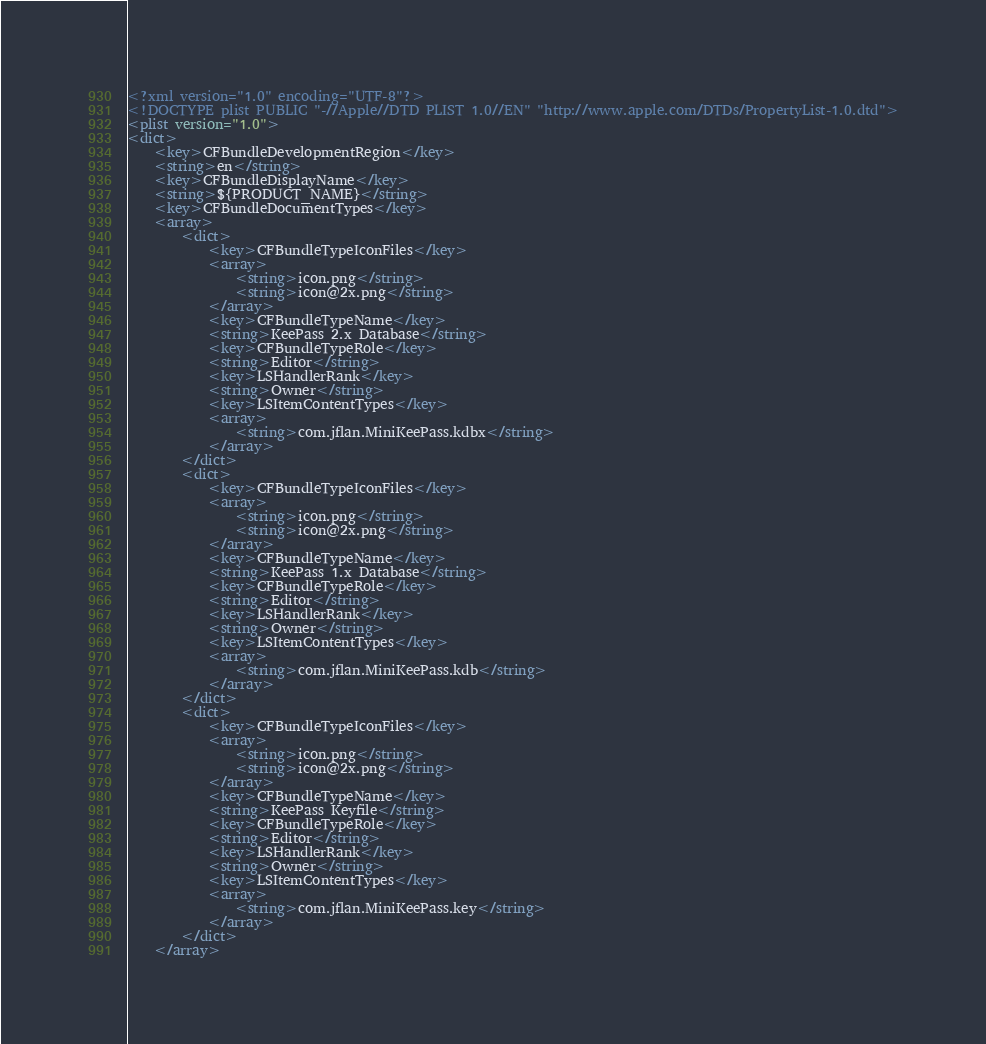<code> <loc_0><loc_0><loc_500><loc_500><_XML_><?xml version="1.0" encoding="UTF-8"?>
<!DOCTYPE plist PUBLIC "-//Apple//DTD PLIST 1.0//EN" "http://www.apple.com/DTDs/PropertyList-1.0.dtd">
<plist version="1.0">
<dict>
	<key>CFBundleDevelopmentRegion</key>
	<string>en</string>
	<key>CFBundleDisplayName</key>
	<string>${PRODUCT_NAME}</string>
	<key>CFBundleDocumentTypes</key>
	<array>
		<dict>
			<key>CFBundleTypeIconFiles</key>
			<array>
				<string>icon.png</string>
				<string>icon@2x.png</string>
			</array>
			<key>CFBundleTypeName</key>
			<string>KeePass 2.x Database</string>
			<key>CFBundleTypeRole</key>
			<string>Editor</string>
			<key>LSHandlerRank</key>
			<string>Owner</string>
			<key>LSItemContentTypes</key>
			<array>
				<string>com.jflan.MiniKeePass.kdbx</string>
			</array>
		</dict>
		<dict>
			<key>CFBundleTypeIconFiles</key>
			<array>
				<string>icon.png</string>
				<string>icon@2x.png</string>
			</array>
			<key>CFBundleTypeName</key>
			<string>KeePass 1.x Database</string>
			<key>CFBundleTypeRole</key>
			<string>Editor</string>
			<key>LSHandlerRank</key>
			<string>Owner</string>
			<key>LSItemContentTypes</key>
			<array>
				<string>com.jflan.MiniKeePass.kdb</string>
			</array>
		</dict>
		<dict>
			<key>CFBundleTypeIconFiles</key>
			<array>
				<string>icon.png</string>
				<string>icon@2x.png</string>
			</array>
			<key>CFBundleTypeName</key>
			<string>KeePass Keyfile</string>
			<key>CFBundleTypeRole</key>
			<string>Editor</string>
			<key>LSHandlerRank</key>
			<string>Owner</string>
			<key>LSItemContentTypes</key>
			<array>
				<string>com.jflan.MiniKeePass.key</string>
			</array>
		</dict>
	</array></code> 